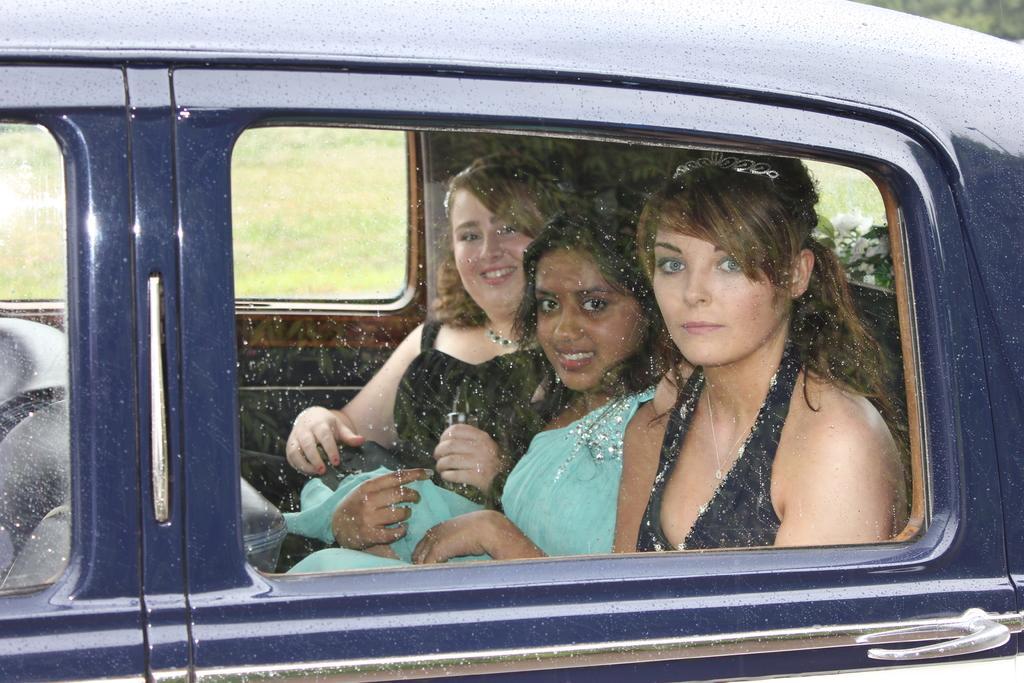In one or two sentences, can you explain what this image depicts? This picture shows three women travelling in a car 